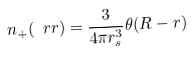Convert formula to latex. <formula><loc_0><loc_0><loc_500><loc_500>n _ { + } ( \ r r ) = \frac { 3 } { 4 \pi r _ { s } ^ { 3 } } \theta ( R - r )</formula> 